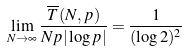<formula> <loc_0><loc_0><loc_500><loc_500>\lim _ { N \to \infty } \frac { \overline { T } ( N , p ) } { N p | \log p | } = \frac { 1 } { ( \log 2 ) ^ { 2 } } \</formula> 